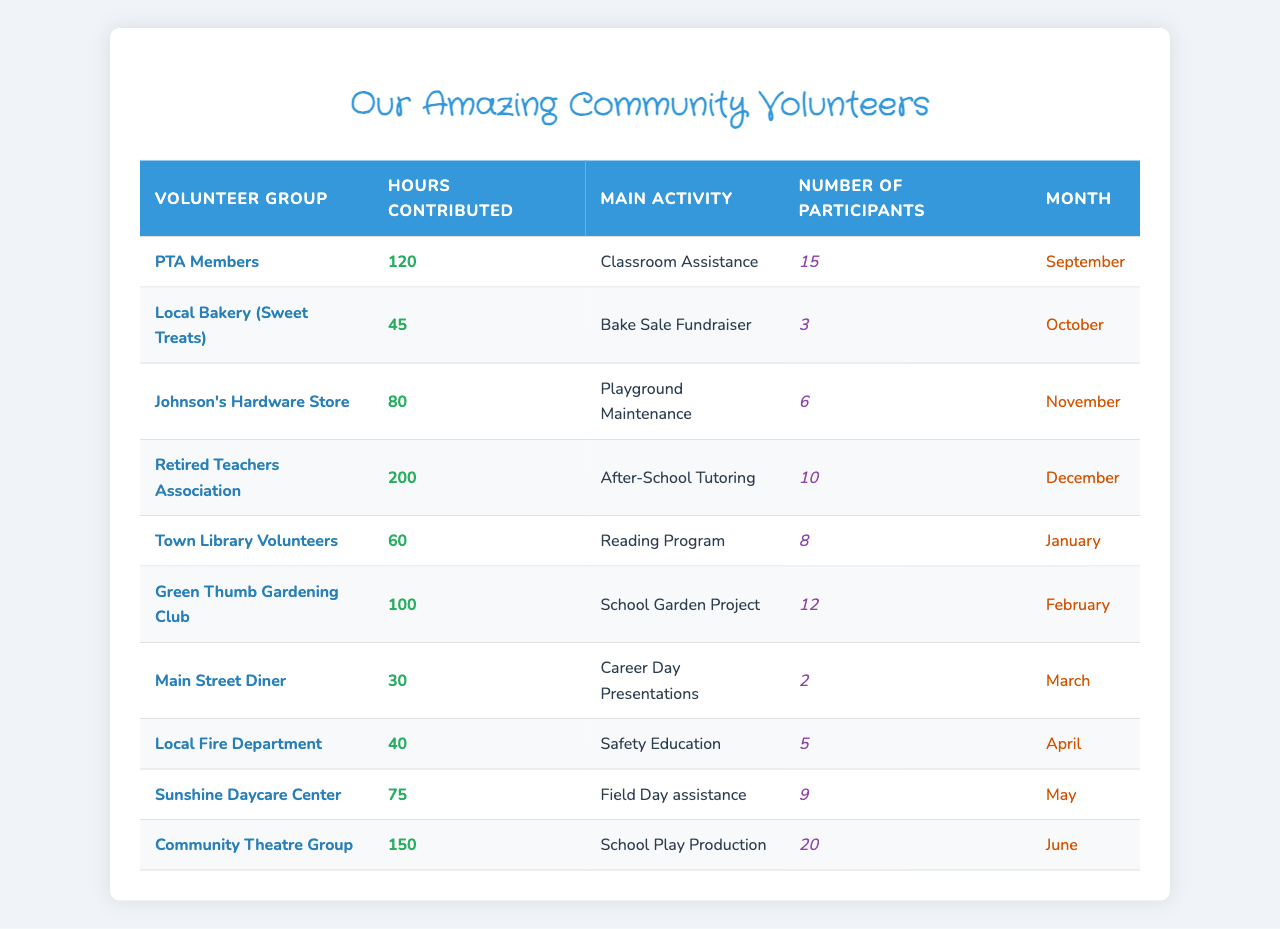What is the total number of hours contributed by the PTA Members? The table lists "PTA Members" under "Volunteer Group" with "120" in the "Hours Contributed" column. Therefore, the total hours contributed by the PTA Members is simply 120.
Answer: 120 Which activity had the highest number of volunteer hours? By looking at the "Hours Contributed" values across all activities, the highest is 200 hours contributed by the "Retired Teachers Association" for "After-School Tutoring."
Answer: After-School Tutoring How many participants assisted in the "School Play Production"? In the "Number of Participants" column corresponding to "Community Theatre Group," there are 20 participants listed for "School Play Production."
Answer: 20 What is the average number of hours contributed by local businesses? The local businesses listed are "Local Bakery," "Johnson's Hardware Store," "Main Street Diner," and "Community Theatre Group" with hours of 45, 80, 30, and 150 respectively. The total contributions from local businesses are 45 + 80 + 30 + 150 = 305 hours. There are 4 local businesses, so the average is 305 / 4 = 76.25.
Answer: 76.25 Did the "Sunshine Daycare Center" contribute more hours than the "Local Bakery"? "Sunshine Daycare Center" contributed 75 hours and "Local Bakery" contributed 45 hours. Since 75 is greater than 45, the statement is true.
Answer: Yes What is the difference in hours contributed between "Retired Teachers Association" and "Main Street Diner"? The "Retired Teachers Association" contributed 200 hours, while the "Main Street Diner" contributed 30 hours. Subtracting gives 200 - 30 = 170 hours difference.
Answer: 170 Which month saw the least number of volunteer hours contributed? By summing up hours for each month, "March" (30), "April" (40), and then comparing them shows that "Main Street Diner" contributed the least at 30 hours, thus March had the least contribution.
Answer: March How many different volunteer groups contributed more than 50 hours in total? The groups contributing more than 50 hours are "PTA Members" (120), "Retired Teachers Association" (200), "Green Thumb Gardening Club" (100), and "Community Theatre Group" (150). Counting them gives 4 groups.
Answer: 4 What was the total number of participants across all volunteer groups? By summing the "Number of Participants": 15 + 3 + 6 + 10 + 8 + 12 + 2 + 5 + 9 + 20, the total is 90 participants in all volunteer activities.
Answer: 90 How many hours were contributed by groups focusing on educational activities? The "PTA Members" (120), "Retired Teachers Association" (200), "Town Library Volunteers" (60), and "Local Fire Department" (40) are identified as educational. Their total contribution is 120 + 200 + 60 + 40 = 420 hours.
Answer: 420 